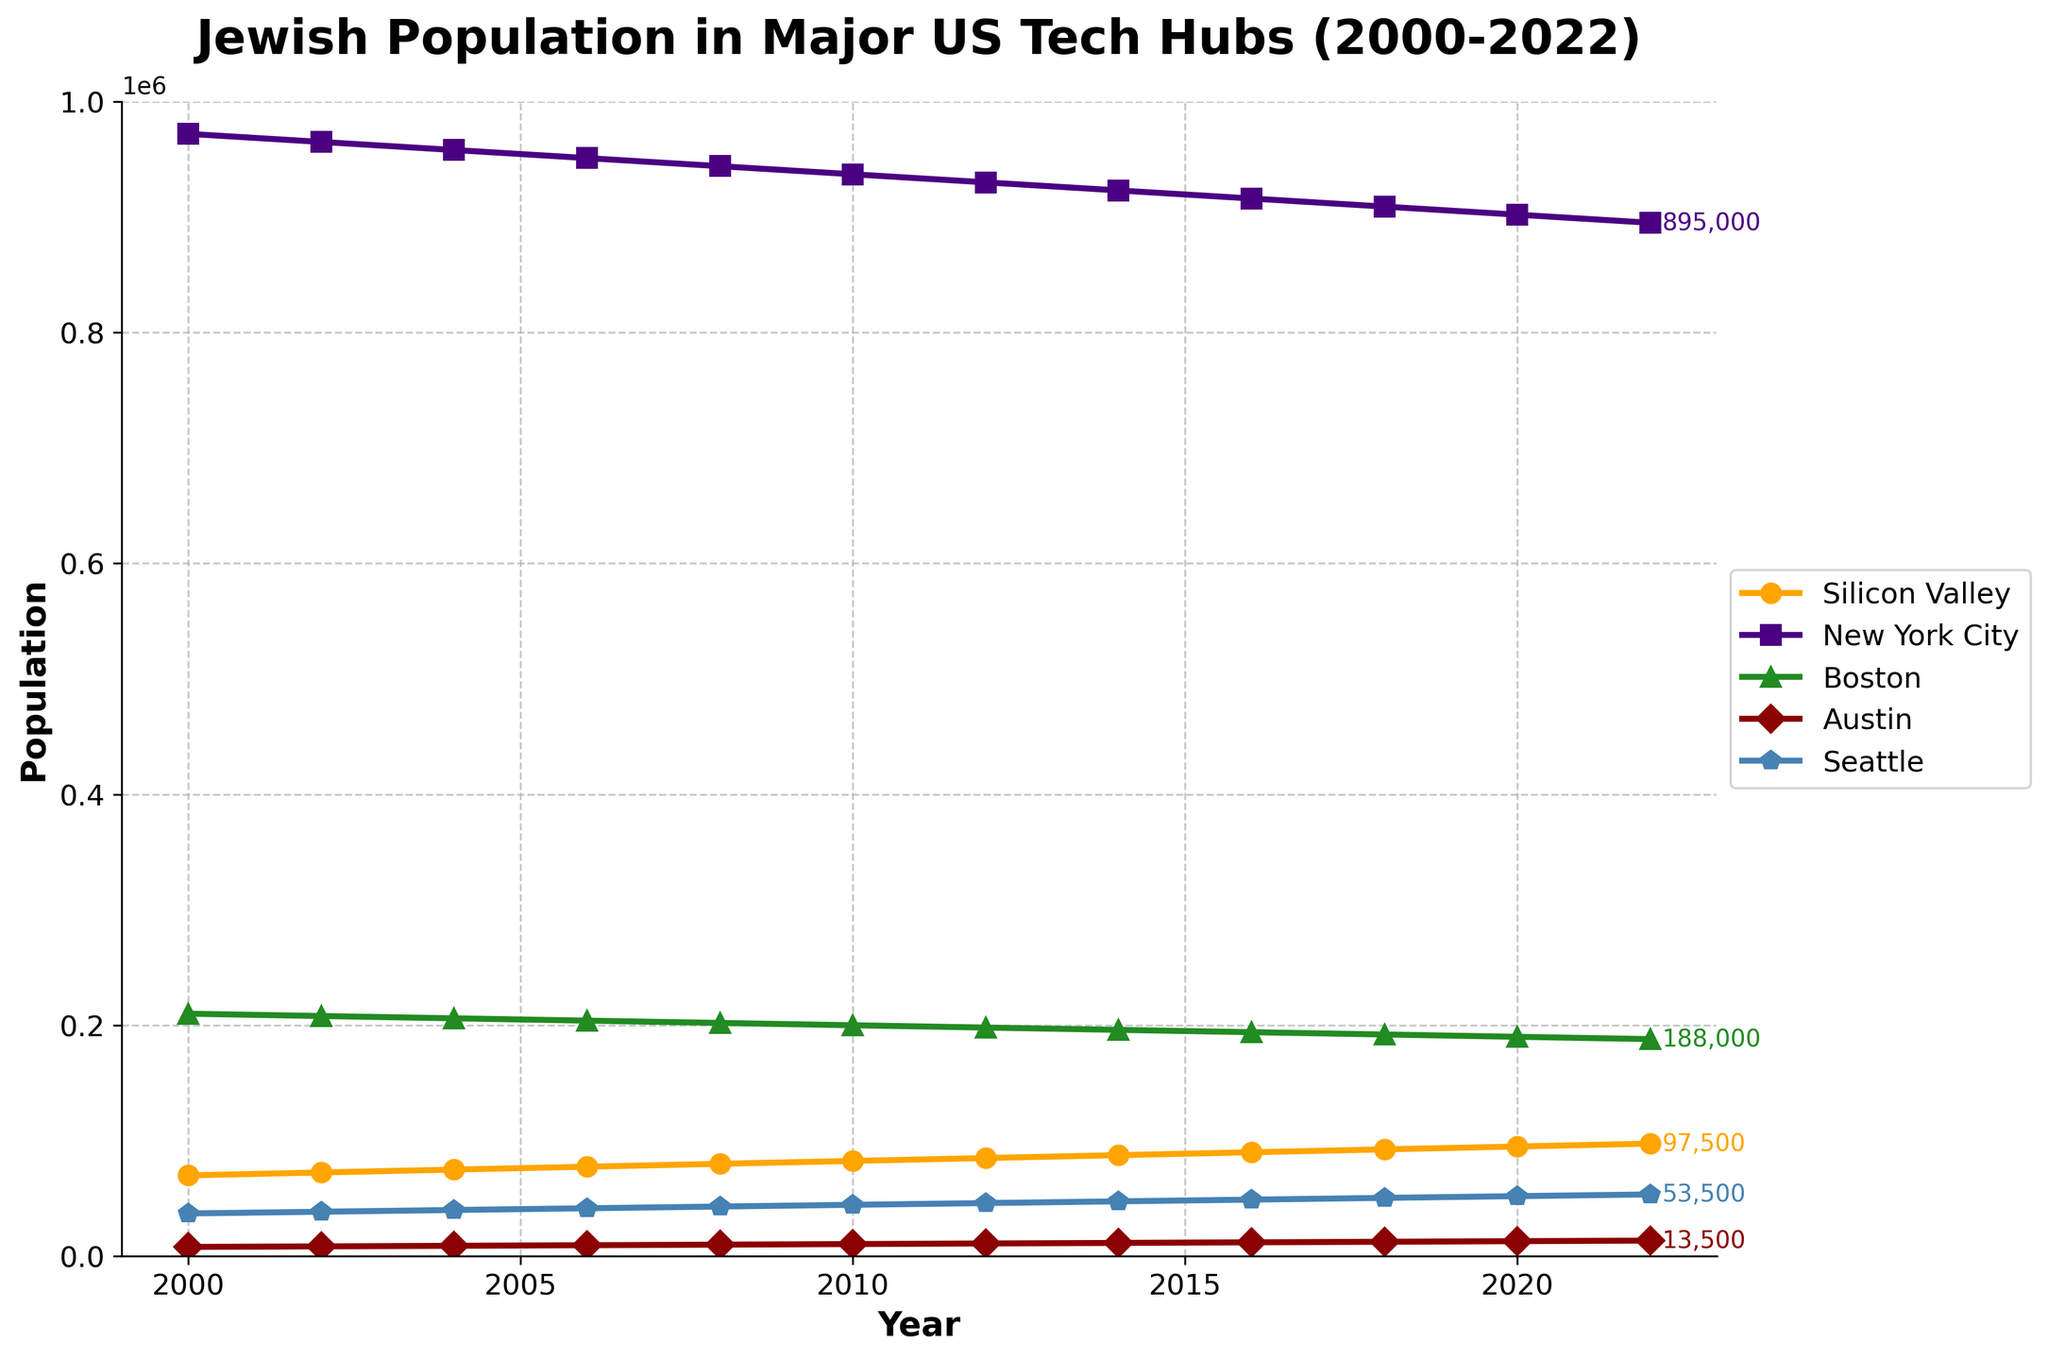what trend can be observed in the Jewish population of New York City from 2000 to 2022? The line for New York City shows a downward trend, gradually decreasing from 972,000 in 2000 to 895,000 in 2022. This indicates a consistent decline over the years.
Answer: A consistent decline Which tech hub had the lowest Jewish population in the year 2000? By examining the lines for all the tech hubs in the year 2000, Austin had the lowest population at 8,000.
Answer: Austin Between which years did Silicon Valley's Jewish population cross the 90,000 mark? Tracking the line for Silicon Valley, it crosses the 90,000 mark between 2016 and 2018.
Answer: 2016 and 2018 What is the difference in Jewish population for Boston between the years 2000 and 2022? In 2000, Boston's Jewish population was 210,000. By 2022, it had decreased to 188,000. The difference is 210,000 - 188,000 = 22,000.
Answer: 22,000 In 2010, which city had a Jewish population closest to that of Seattle in 2022? In 2010, Seattle had a Jewish population of 44,500. In 2022, Seattle's population was 53,500. Comparing the 2010 data, Austin had a population of 10,500, which is not close. Among the cities in 2012, the city closest to 2022 Seattle is Seattle itself.
Answer: Seattle How many cities had an increasing trend in Jewish population from 2000 to 2022? Observing the lines for each city from 2000 to 2022, Silicon Valley, Austin, and Seattle show an increasing trend. Hence, three cities had an increasing trend.
Answer: Three What is the population gap between the cities with the highest and lowest Jewish populations in 2022? In 2022, New York City had the highest population at 895,000, and Austin had the lowest at 13,500. The gap is 895,000 - 13,500 = 881,500.
Answer: 881,500 Is there any year when New York City's Jewish population dipped below 900,000? Examining the line for New York City, it dipped below 900,000 after 2020. In 2022, the population is 895,000.
Answer: Yes What is the average annual increase for Silicon Valley from 2000 to 2022? Silicon Valley's population increased from 70,000 in 2000 to 97,500 in 2022. The increase is 97,500 - 70,000 = 27,500, over 22 years. The average annual increase is 27,500 / 22 ≈ 1,250.
Answer: 1,250 Which city had the smallest increase in population from 2000 to 2022? Comparing the starting and ending points for each city, New York City decreased, and Boston decreased. Among the increasing cities, Austin increased by 5,500 (13,500 - 8,000) and Seattle by 16,500 (53,500 - 37,000). Therefore, Austin had the smallest increase at 5,500.
Answer: Austin Between which years did Austin have the largest increase in Jewish population? By analyzing the slopes in Austin's population line, between 2018 and 2020, Austin's population increased from 12,500 to 13,000, marking a rise of 500, the largest increase in the dataset.
Answer: 2018 and 2020 